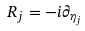Convert formula to latex. <formula><loc_0><loc_0><loc_500><loc_500>R _ { j } = - i \partial _ { \eta _ { j } }</formula> 